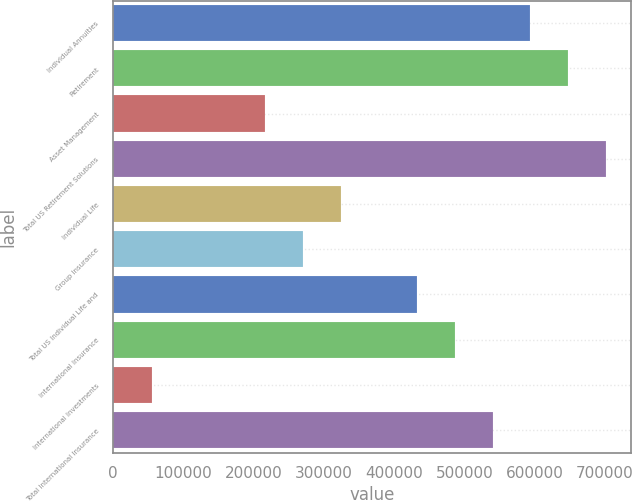Convert chart. <chart><loc_0><loc_0><loc_500><loc_500><bar_chart><fcel>Individual Annuities<fcel>Retirement<fcel>Asset Management<fcel>Total US Retirement Solutions<fcel>Individual Life<fcel>Group Insurance<fcel>Total US Individual Life and<fcel>International Insurance<fcel>International Investments<fcel>Total International Insurance<nl><fcel>593771<fcel>647688<fcel>216353<fcel>701605<fcel>324186<fcel>270270<fcel>432020<fcel>485937<fcel>54601.9<fcel>539854<nl></chart> 